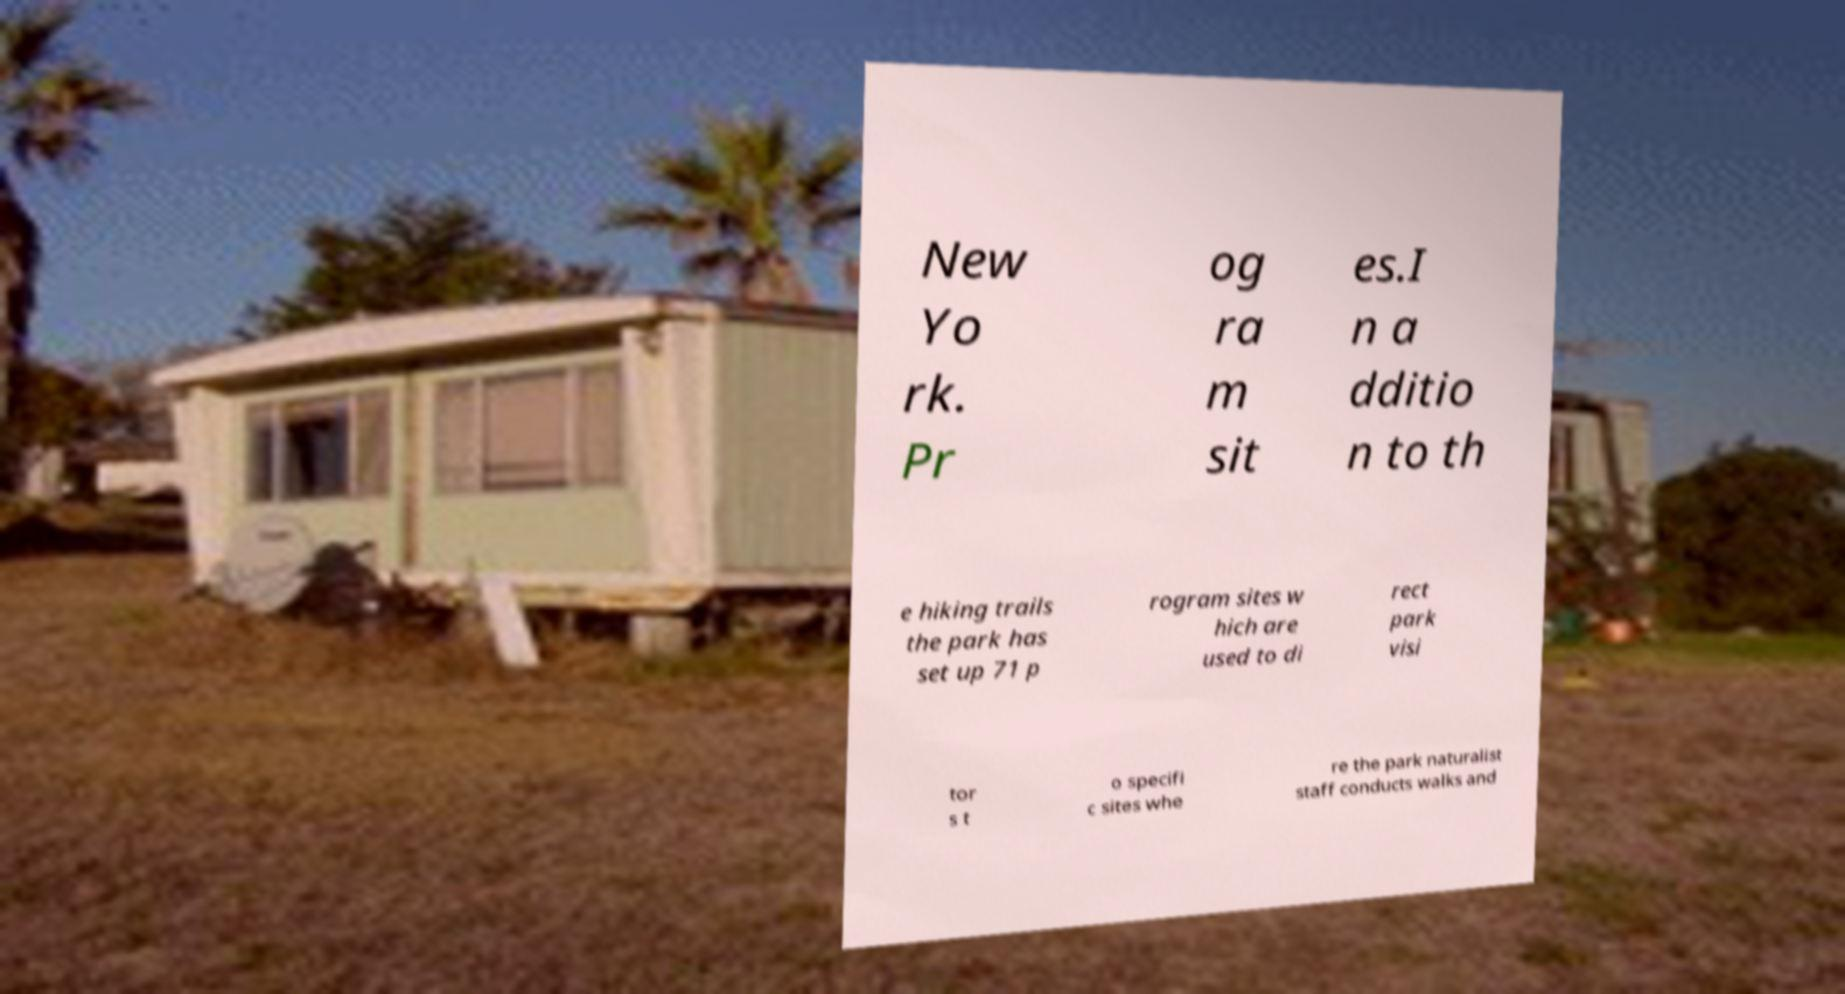What messages or text are displayed in this image? I need them in a readable, typed format. New Yo rk. Pr og ra m sit es.I n a dditio n to th e hiking trails the park has set up 71 p rogram sites w hich are used to di rect park visi tor s t o specifi c sites whe re the park naturalist staff conducts walks and 